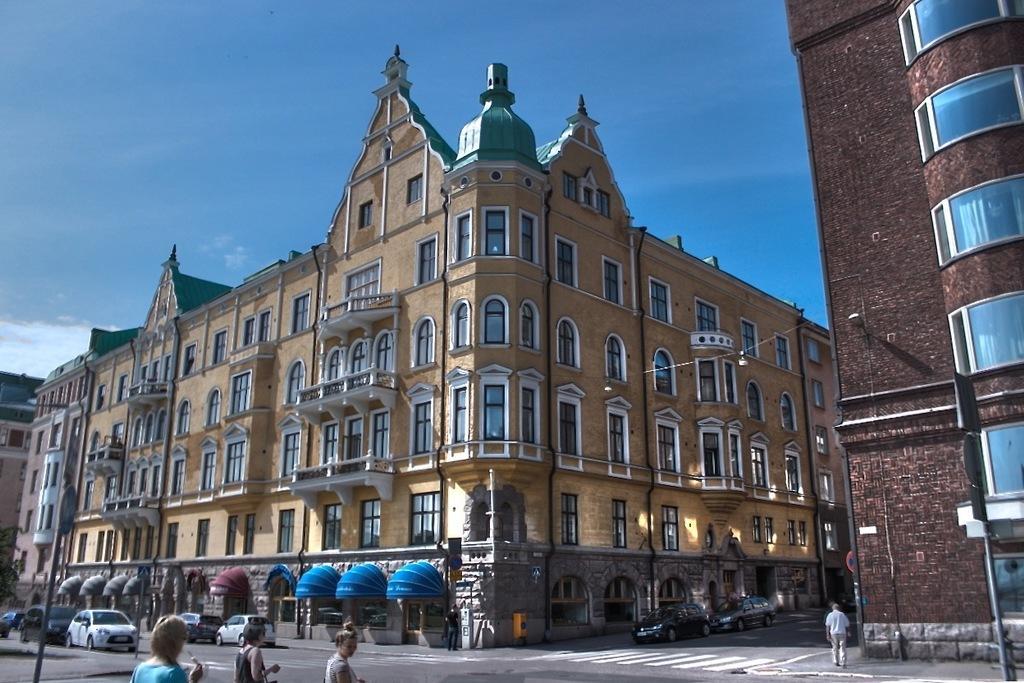How would you summarize this image in a sentence or two? In this picture I can see few persons and vehicles at the bottom, in the middle there are buildings, at the top I can see the sky. 